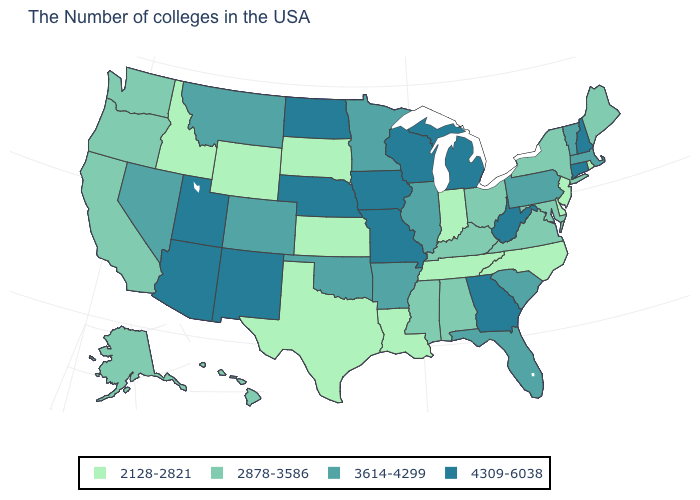What is the value of Illinois?
Keep it brief. 3614-4299. What is the value of Rhode Island?
Answer briefly. 2128-2821. What is the highest value in the USA?
Short answer required. 4309-6038. What is the value of Montana?
Give a very brief answer. 3614-4299. Name the states that have a value in the range 3614-4299?
Write a very short answer. Massachusetts, Vermont, Pennsylvania, South Carolina, Florida, Illinois, Arkansas, Minnesota, Oklahoma, Colorado, Montana, Nevada. What is the value of Rhode Island?
Concise answer only. 2128-2821. Does Louisiana have the highest value in the USA?
Write a very short answer. No. What is the value of Indiana?
Answer briefly. 2128-2821. What is the value of Hawaii?
Answer briefly. 2878-3586. What is the value of Alabama?
Quick response, please. 2878-3586. Does Hawaii have the same value as Mississippi?
Give a very brief answer. Yes. Does West Virginia have a higher value than Iowa?
Be succinct. No. Does Georgia have the highest value in the South?
Answer briefly. Yes. Which states have the lowest value in the Northeast?
Be succinct. Rhode Island, New Jersey. Name the states that have a value in the range 4309-6038?
Give a very brief answer. New Hampshire, Connecticut, West Virginia, Georgia, Michigan, Wisconsin, Missouri, Iowa, Nebraska, North Dakota, New Mexico, Utah, Arizona. 